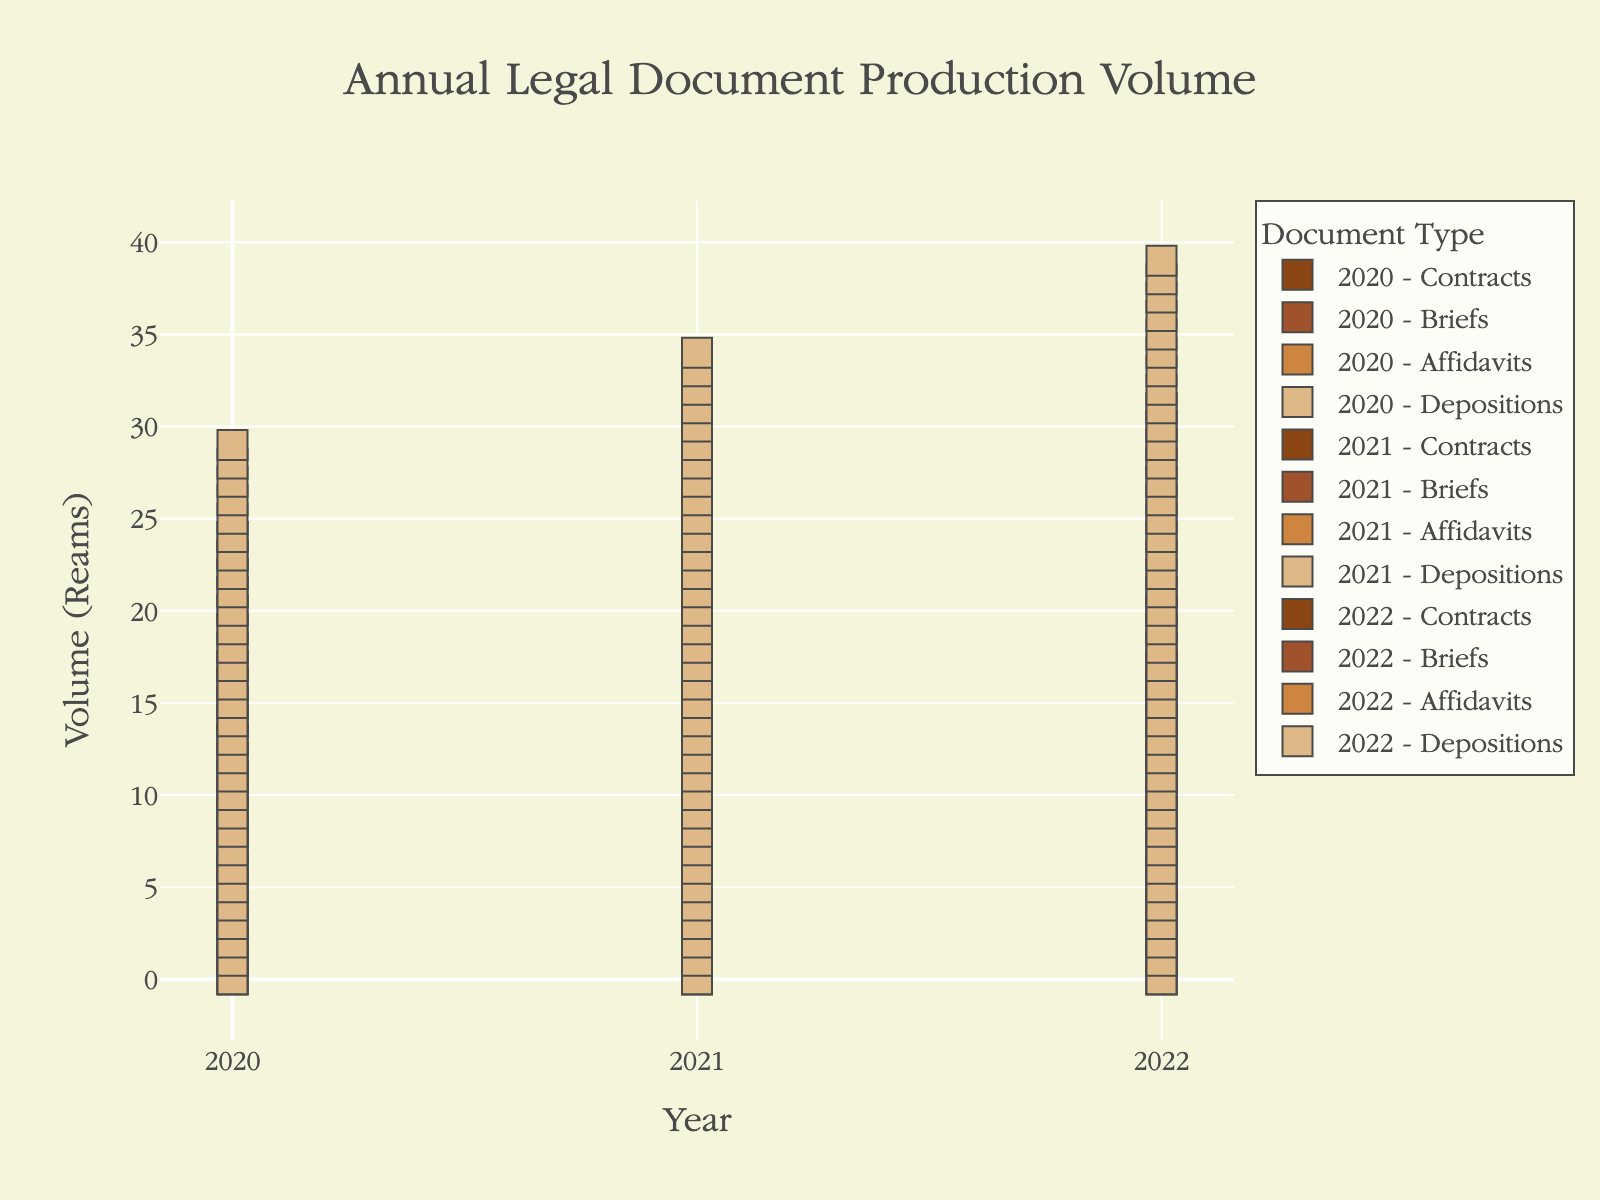what is the volume of Contracts in 2020? Identify the number of paper icons in the stack corresponding to 'Contracts' for the year 2020. There are 25 icons.
Answer: 25 how many reams of Briefs were produced in 2021 compared to 2020? Identify the heights of the stacks for 'Briefs' in 2020 and 2021. The stack in 2020 shows 18 icons, and in 2021 it shows 20 icons. Subtract 18 from 20, resulting in 2 reams more in 2021.
Answer: 2 which document type had the highest volume in 2022? Compare the heights of the stacks for each document type in 2022. The 'Depositions' stack is the tallest with 40 icons.
Answer: Depositions did the volume of Affidavits increase or decrease from 2020 to 2022? Compare the heights of the stacks for 'Affidavits' in 2020 and 2022. The 2020 stack has 12 icons, while the 2022 stack has 18 icons, indicating an increase.
Answer: Increase what is the total volume of Depositions produced across all years? Add the heights of the stacks for 'Depositions' across 2020, 2021, and 2022. The stacks show 30, 35, and 40 icons respectively. Summing these values results in 105 icons.
Answer: 105 which year had the lowest total document production volume? For each year, sum the heights of all stacks. For 2020: 25+18+12+30=85. For 2021: 28+20+15+35=98. For 2022: 32+22+18+40=112. The year 2020 has the lowest total with 85 reams.
Answer: 2020 what is the average volume of legal documents produced per year for Briefs? Sum the volumes of 'Briefs' for each year and divide by the number of years. The values are 18, 20, and 22 reams. Summing these results in 60, and dividing by 3 gives an average of 20 reams.
Answer: 20 did any document type maintain a constant production volume across all three years? Compare the stack heights for each document type across the years. None of the document types have the same heights across all three years.
Answer: None 